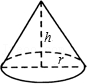Depict what you see in the visual. The diagram illustrates a cone with a circular base. The base is labeled with a radius. The cone extends upward from the base, and its height is labeled. The lateral surface of the cone is the curved part that connects the base to the apex. 